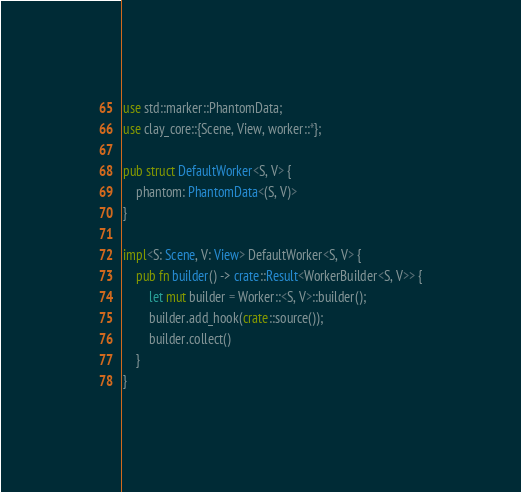Convert code to text. <code><loc_0><loc_0><loc_500><loc_500><_Rust_>use std::marker::PhantomData;
use clay_core::{Scene, View, worker::*};

pub struct DefaultWorker<S, V> {
    phantom: PhantomData<(S, V)>
}

impl<S: Scene, V: View> DefaultWorker<S, V> {
    pub fn builder() -> crate::Result<WorkerBuilder<S, V>> {
        let mut builder = Worker::<S, V>::builder();
        builder.add_hook(crate::source());
        builder.collect()
    }
}
</code> 